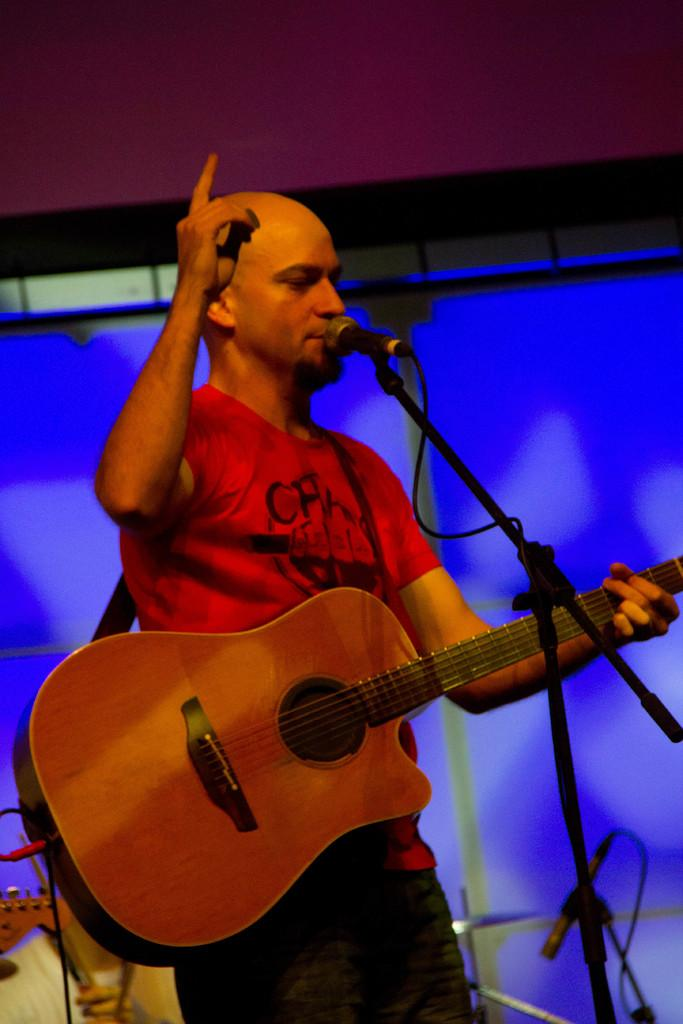What is the main subject of the image? The main subject of the image is a man standing at the center. What is the man holding in his hand? The man is holding a guitar in his hand. What is the man doing with the microphone? The man is speaking on a microphone. How many rabbits can be seen in the image? There are no rabbits present in the image. What type of donkey is visible in the image? There is no donkey present in the image. 